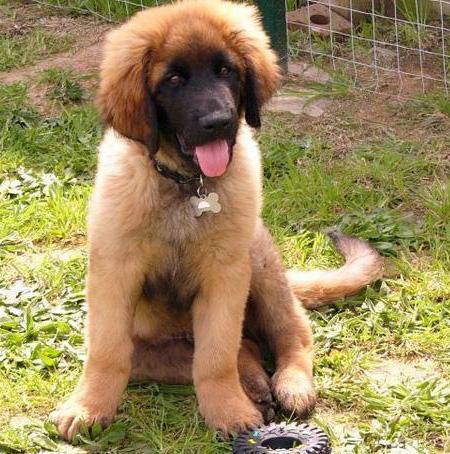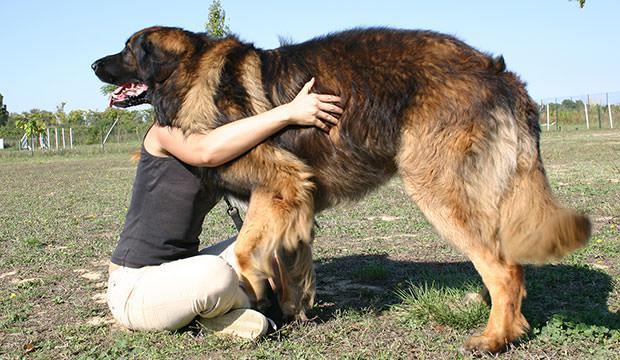The first image is the image on the left, the second image is the image on the right. Evaluate the accuracy of this statement regarding the images: "A person is touching a dog". Is it true? Answer yes or no. Yes. 